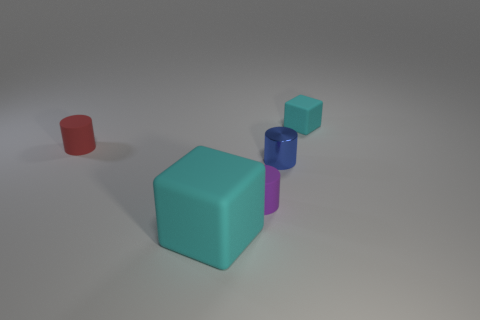Subtract all tiny blue shiny cylinders. How many cylinders are left? 2 Add 5 tiny red cubes. How many objects exist? 10 Subtract all cubes. How many objects are left? 3 Subtract all purple cylinders. How many cylinders are left? 2 Subtract 1 cubes. How many cubes are left? 1 Subtract 1 blue cylinders. How many objects are left? 4 Subtract all brown blocks. Subtract all yellow balls. How many blocks are left? 2 Subtract all green cylinders. How many green cubes are left? 0 Subtract all tiny yellow shiny blocks. Subtract all small purple rubber objects. How many objects are left? 4 Add 4 tiny red matte cylinders. How many tiny red matte cylinders are left? 5 